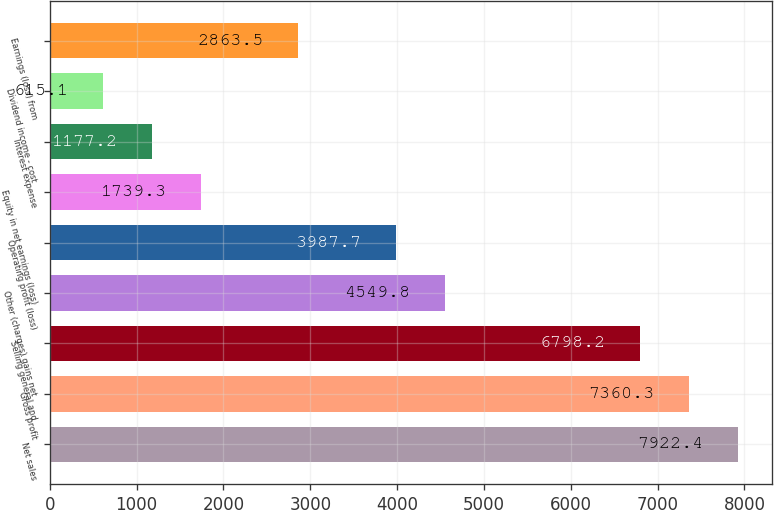Convert chart to OTSL. <chart><loc_0><loc_0><loc_500><loc_500><bar_chart><fcel>Net sales<fcel>Gross profit<fcel>Selling general and<fcel>Other (charges) gains net<fcel>Operating profit (loss)<fcel>Equity in net earnings (loss)<fcel>Interest expense<fcel>Dividend income - cost<fcel>Earnings (loss) from<nl><fcel>7922.4<fcel>7360.3<fcel>6798.2<fcel>4549.8<fcel>3987.7<fcel>1739.3<fcel>1177.2<fcel>615.1<fcel>2863.5<nl></chart> 